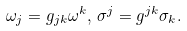<formula> <loc_0><loc_0><loc_500><loc_500>\omega _ { j } = g _ { j k } \omega ^ { k } , \, \sigma ^ { j } = g ^ { j k } \sigma _ { k } .</formula> 